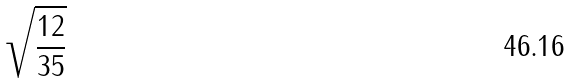<formula> <loc_0><loc_0><loc_500><loc_500>\sqrt { \frac { 1 2 } { 3 5 } }</formula> 